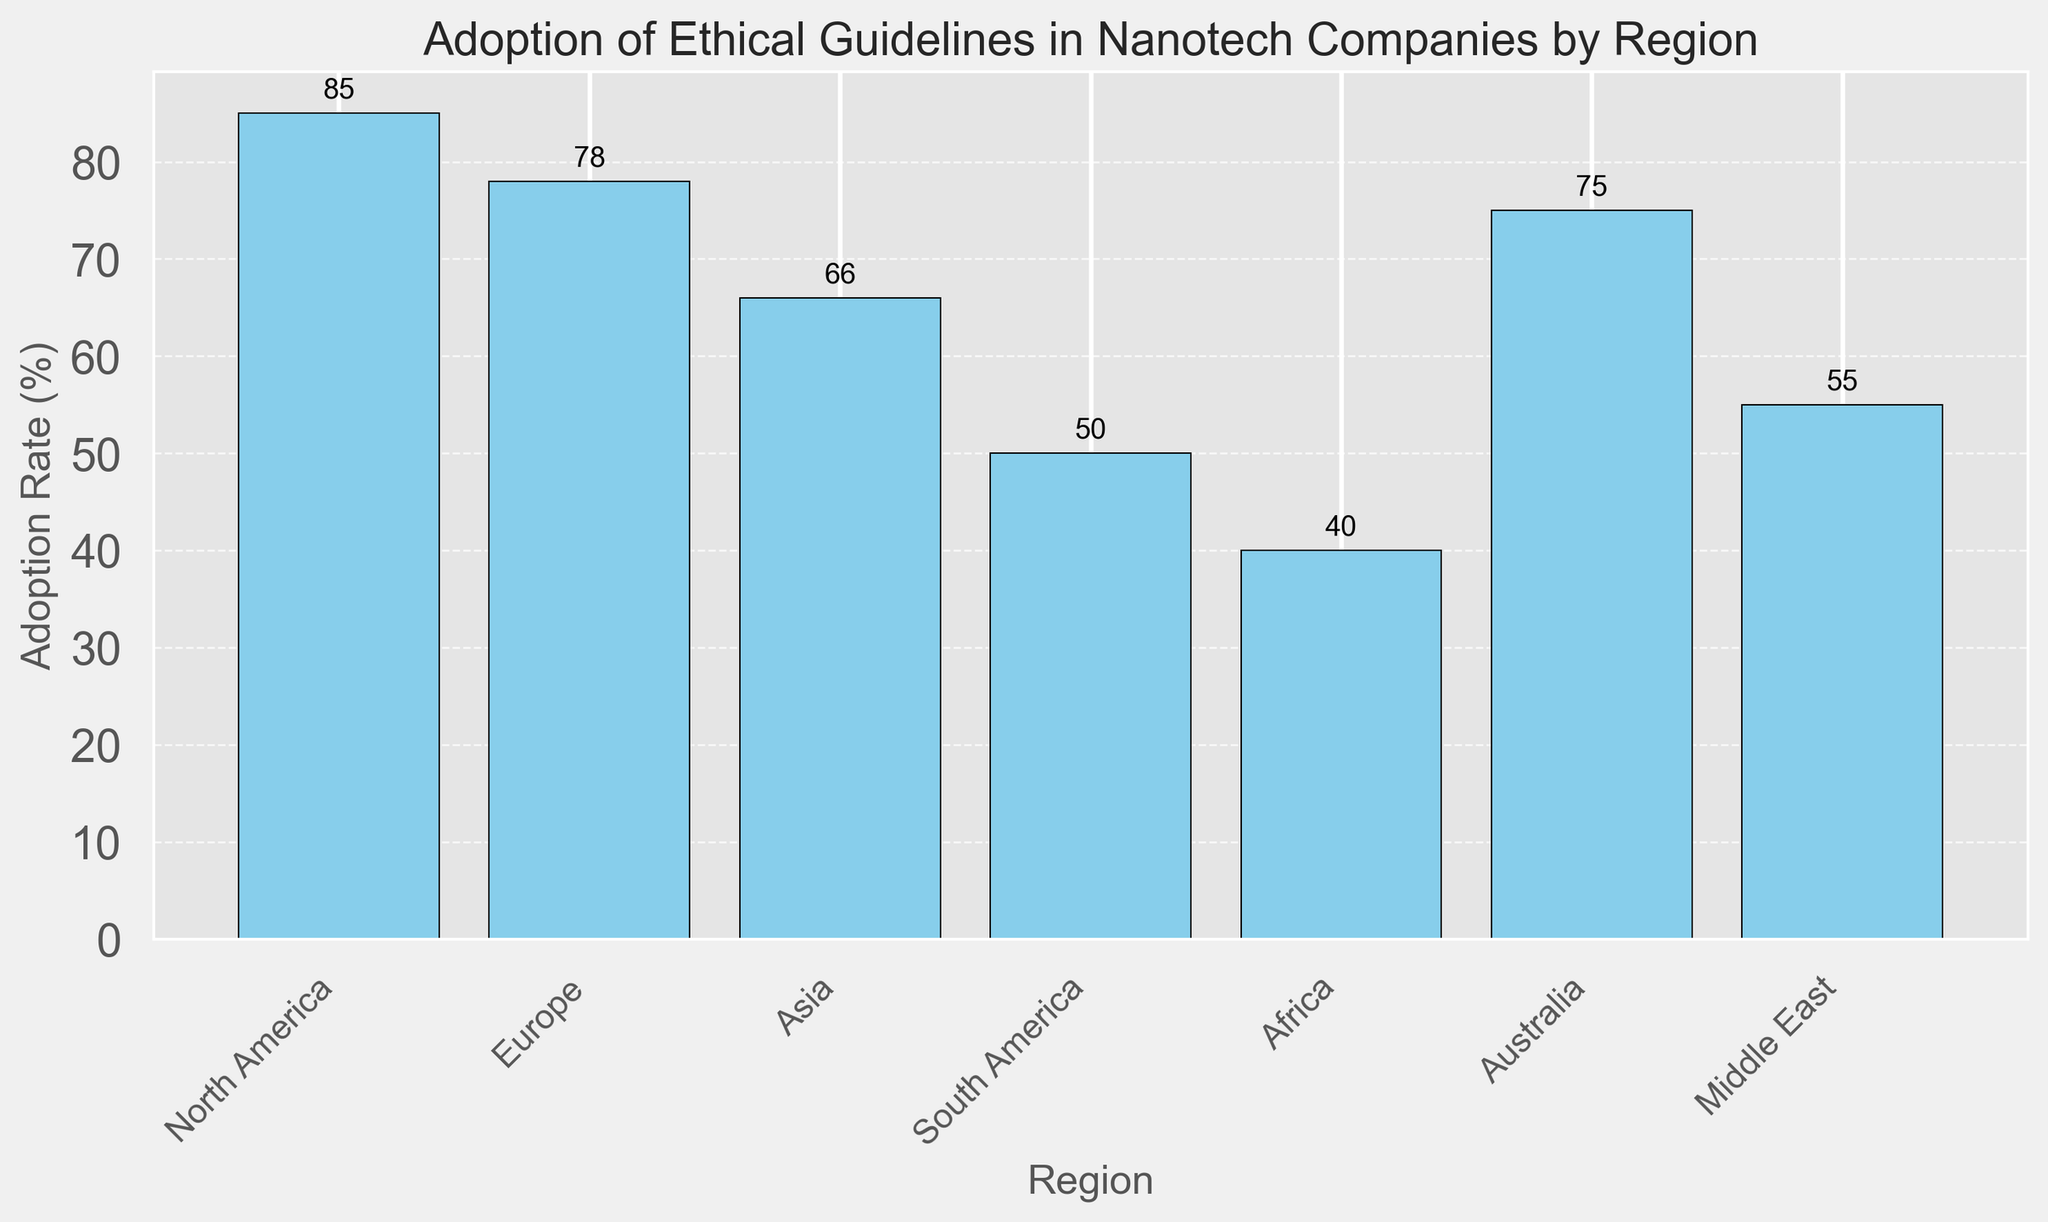Which region has the highest adoption rate of ethical guidelines? The highest bar on the chart represents the region with the highest adoption rate. This is North America.
Answer: North America Which region has the lowest adoption rate of ethical guidelines? The lowest bar on the chart represents the region with the lowest adoption rate. This is Africa.
Answer: Africa How much higher is the adoption rate in North America compared to Asia? Subtract the adoption rate of Asia from that of North America. 85% - 66% = 19%
Answer: 19% What is the average adoption rate across all regions? Add the adoption rates of all regions and divide by the number of regions. (85 + 78 + 66 + 50 + 40 + 75 + 55) / 7 = 449 / 7 ≈ 64.14%
Answer: 64.14% Which regions have an adoption rate higher than the global average? First, find the average rate which is approximately 64.14%. Then, identify regions with a higher adoption rate: North America (85%), Europe (78%), and Australia (75%).
Answer: North America, Europe, Australia What is the difference in the number of companies surveyed between the region with the highest and lowest adoption rates? North America has 150 companies surveyed while Africa has 60. The difference is 150 - 60 = 90.
Answer: 90 Among Europe and the Middle East, which region has a higher adoption rate, and by how much? Europe has an adoption rate of 78%, and the Middle East has 55%. The difference is 78% - 55% = 23%.
Answer: Europe, 23% What is the combined adoption rate of the regions with the lowest and highest adoption rates? North America has the highest adoption rate (85%), and Africa has the lowest (40%). Add these together: 85% + 40% = 125%.
Answer: 125% What percentage of the total number of companies surveyed comes from North America? Sum all companies surveyed: 150 + 130 + 170 + 70 + 60 + 40 + 50 = 670. North America has 150 companies. Calculate percentage: (150/670) * 100 ≈ 22.39%.
Answer: 22.39% How many regions have an adoption rate below 60%? Identify the bars lower than 60% on the chart: Asia (66%), South America (50%), Africa (40%), Middle East (55%). Counting these gives 3 regions.
Answer: 3 regions 